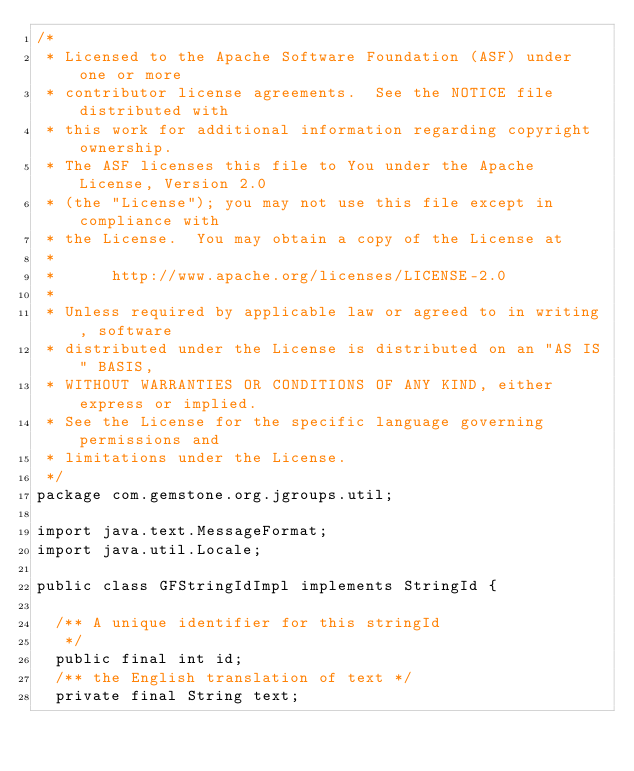Convert code to text. <code><loc_0><loc_0><loc_500><loc_500><_Java_>/*
 * Licensed to the Apache Software Foundation (ASF) under one or more
 * contributor license agreements.  See the NOTICE file distributed with
 * this work for additional information regarding copyright ownership.
 * The ASF licenses this file to You under the Apache License, Version 2.0
 * (the "License"); you may not use this file except in compliance with
 * the License.  You may obtain a copy of the License at
 *
 *      http://www.apache.org/licenses/LICENSE-2.0
 *
 * Unless required by applicable law or agreed to in writing, software
 * distributed under the License is distributed on an "AS IS" BASIS,
 * WITHOUT WARRANTIES OR CONDITIONS OF ANY KIND, either express or implied.
 * See the License for the specific language governing permissions and
 * limitations under the License.
 */
package com.gemstone.org.jgroups.util;

import java.text.MessageFormat;
import java.util.Locale;

public class GFStringIdImpl implements StringId {

  /** A unique identifier for this stringId
   */
  public final int id;
  /** the English translation of text */
  private final String text;
</code> 